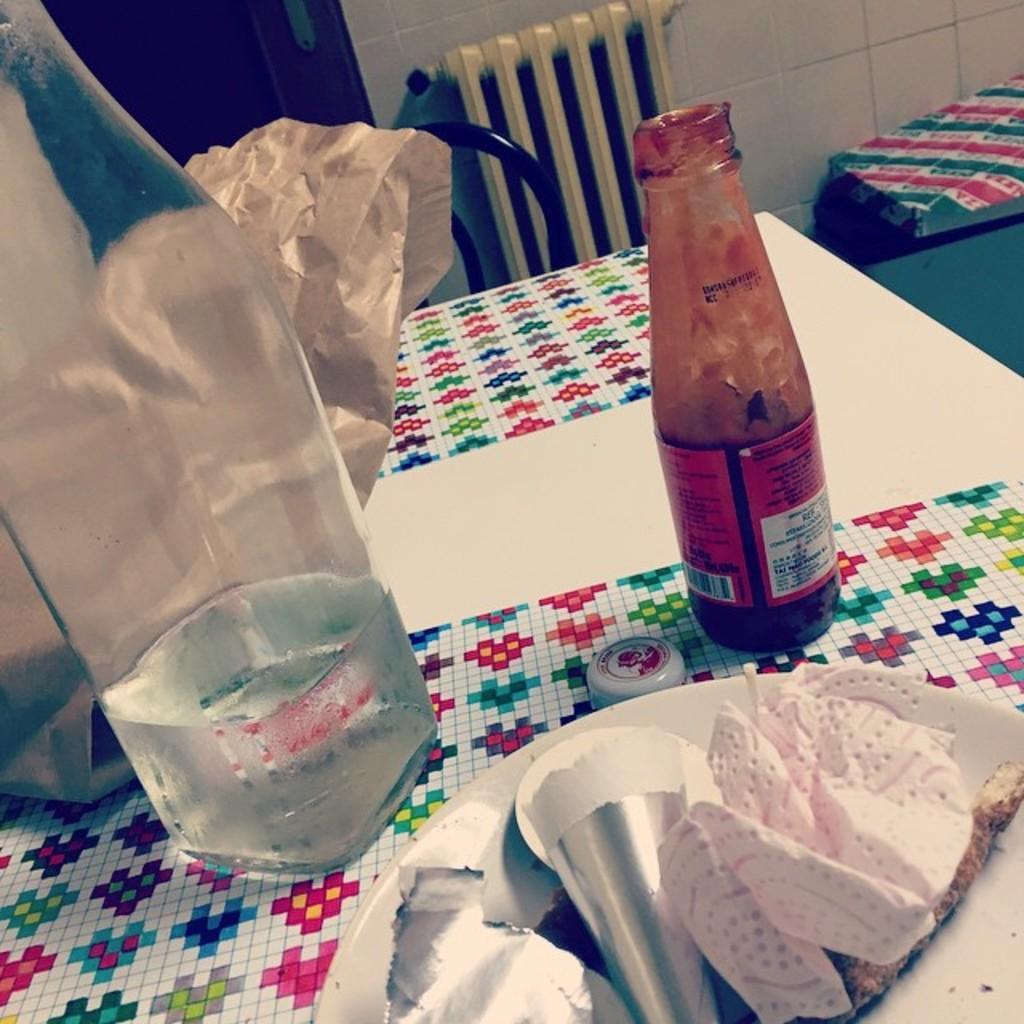In one or two sentences, can you explain what this image depicts? On the white color table there are plates with tissue and wrappers on it, a bottle with liquid in it, ketchup bottle and one cove. To the backside of the table there is a chair. 